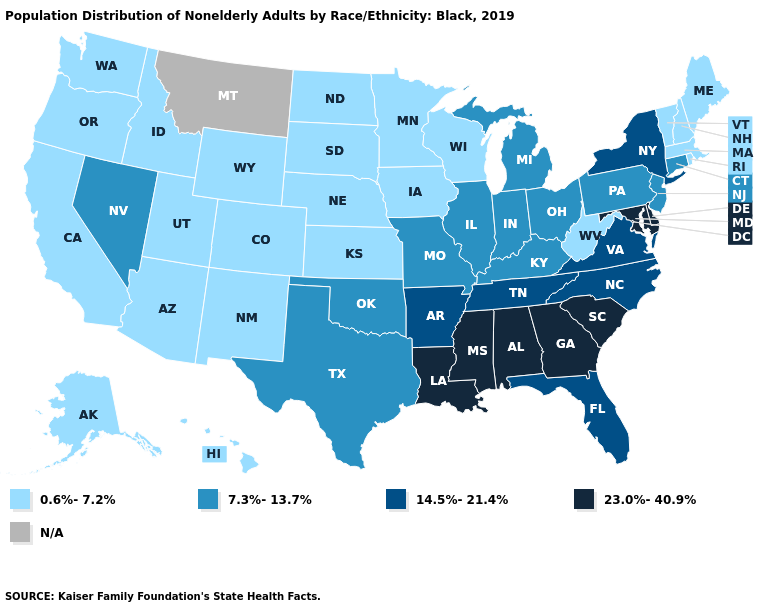Does the first symbol in the legend represent the smallest category?
Concise answer only. Yes. Name the states that have a value in the range 0.6%-7.2%?
Answer briefly. Alaska, Arizona, California, Colorado, Hawaii, Idaho, Iowa, Kansas, Maine, Massachusetts, Minnesota, Nebraska, New Hampshire, New Mexico, North Dakota, Oregon, Rhode Island, South Dakota, Utah, Vermont, Washington, West Virginia, Wisconsin, Wyoming. Which states have the highest value in the USA?
Keep it brief. Alabama, Delaware, Georgia, Louisiana, Maryland, Mississippi, South Carolina. Does Oklahoma have the lowest value in the USA?
Answer briefly. No. Does Mississippi have the highest value in the USA?
Short answer required. Yes. What is the value of Delaware?
Keep it brief. 23.0%-40.9%. Name the states that have a value in the range 0.6%-7.2%?
Quick response, please. Alaska, Arizona, California, Colorado, Hawaii, Idaho, Iowa, Kansas, Maine, Massachusetts, Minnesota, Nebraska, New Hampshire, New Mexico, North Dakota, Oregon, Rhode Island, South Dakota, Utah, Vermont, Washington, West Virginia, Wisconsin, Wyoming. Name the states that have a value in the range N/A?
Keep it brief. Montana. What is the lowest value in the USA?
Concise answer only. 0.6%-7.2%. Which states have the highest value in the USA?
Be succinct. Alabama, Delaware, Georgia, Louisiana, Maryland, Mississippi, South Carolina. What is the highest value in the MidWest ?
Answer briefly. 7.3%-13.7%. Among the states that border Minnesota , which have the highest value?
Concise answer only. Iowa, North Dakota, South Dakota, Wisconsin. Does Georgia have the highest value in the USA?
Answer briefly. Yes. What is the highest value in states that border Iowa?
Give a very brief answer. 7.3%-13.7%. 